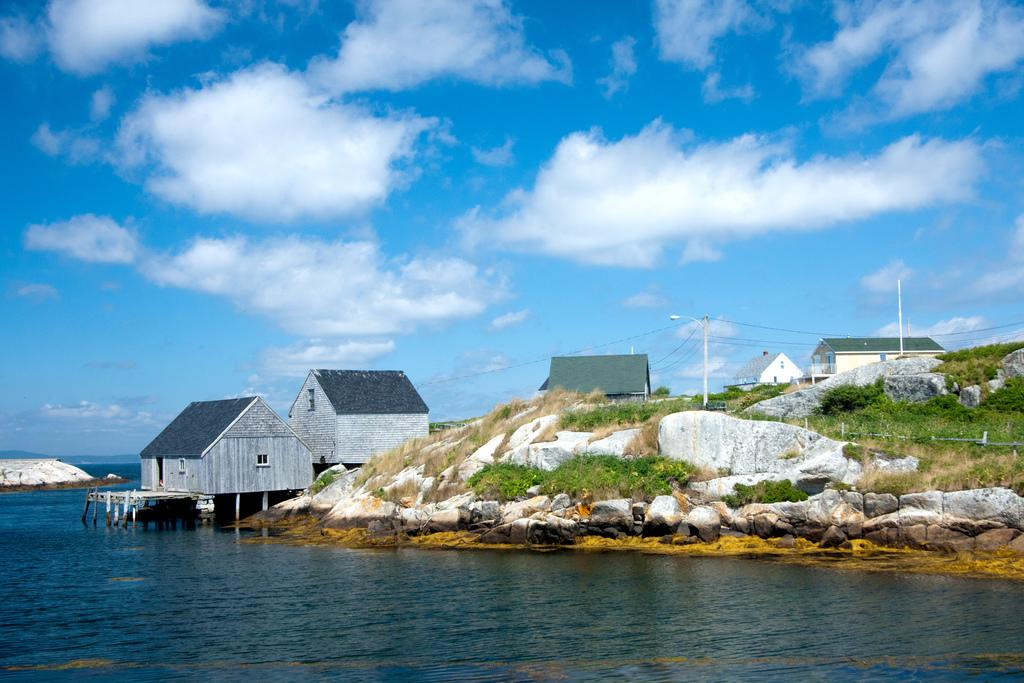What is at the bottom of the image? There is water at the bottom of the image. What can be seen in the middle of the image? There are houses in the middle of the image. What is visible in the background of the image? The background of the image is the sky. Can you see a ladybug crawling on the roof of one of the houses in the image? There is no ladybug present in the image; it only features water, houses, and the sky. Is there a rod attached to any of the houses in the image? There is no rod visible in the image; it only features water, houses, and the sky. 